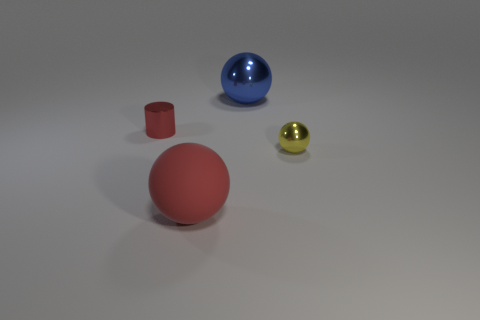Add 2 cylinders. How many objects exist? 6 Subtract all cylinders. How many objects are left? 3 Subtract all tiny yellow spheres. Subtract all big shiny things. How many objects are left? 2 Add 3 tiny metal things. How many tiny metal things are left? 5 Add 3 large red rubber balls. How many large red rubber balls exist? 4 Subtract 1 red spheres. How many objects are left? 3 